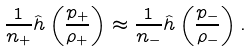Convert formula to latex. <formula><loc_0><loc_0><loc_500><loc_500>\frac { 1 } { n _ { + } } \hat { h } \left ( \frac { p _ { + } } { \rho _ { + } } \right ) \approx \frac { 1 } { n _ { - } } \hat { h } \left ( \frac { p _ { - } } { \rho _ { - } } \right ) .</formula> 